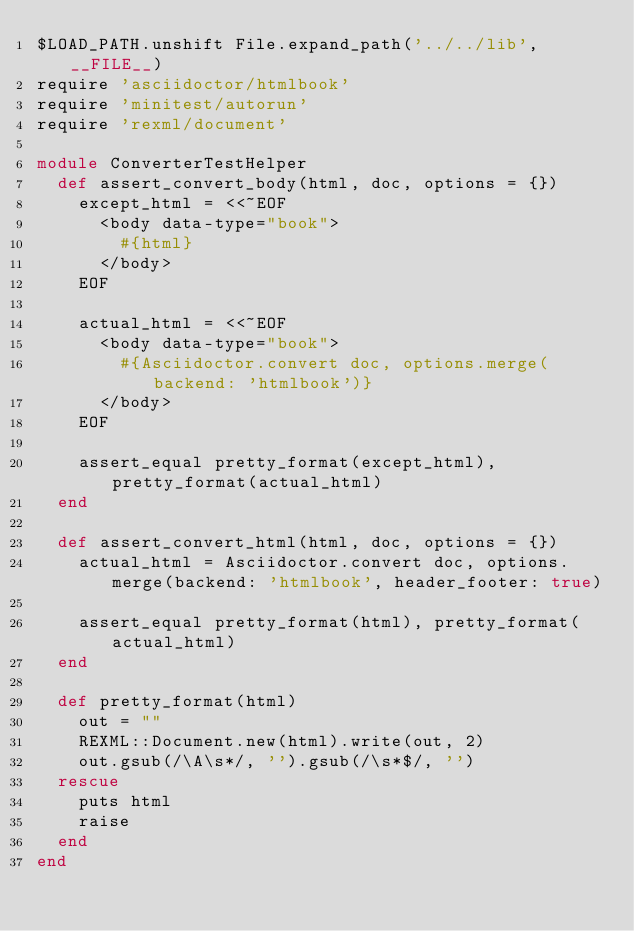Convert code to text. <code><loc_0><loc_0><loc_500><loc_500><_Ruby_>$LOAD_PATH.unshift File.expand_path('../../lib', __FILE__)
require 'asciidoctor/htmlbook'
require 'minitest/autorun'
require 'rexml/document'

module ConverterTestHelper
  def assert_convert_body(html, doc, options = {})
    except_html = <<~EOF
      <body data-type="book">
        #{html}
      </body>
    EOF

    actual_html = <<~EOF
      <body data-type="book">
        #{Asciidoctor.convert doc, options.merge(backend: 'htmlbook')}
      </body>
    EOF

    assert_equal pretty_format(except_html), pretty_format(actual_html)
  end

  def assert_convert_html(html, doc, options = {})
    actual_html = Asciidoctor.convert doc, options.merge(backend: 'htmlbook', header_footer: true)

    assert_equal pretty_format(html), pretty_format(actual_html)
  end

  def pretty_format(html)
    out = ""
    REXML::Document.new(html).write(out, 2)
    out.gsub(/\A\s*/, '').gsub(/\s*$/, '')
  rescue
    puts html
    raise
  end
end
</code> 